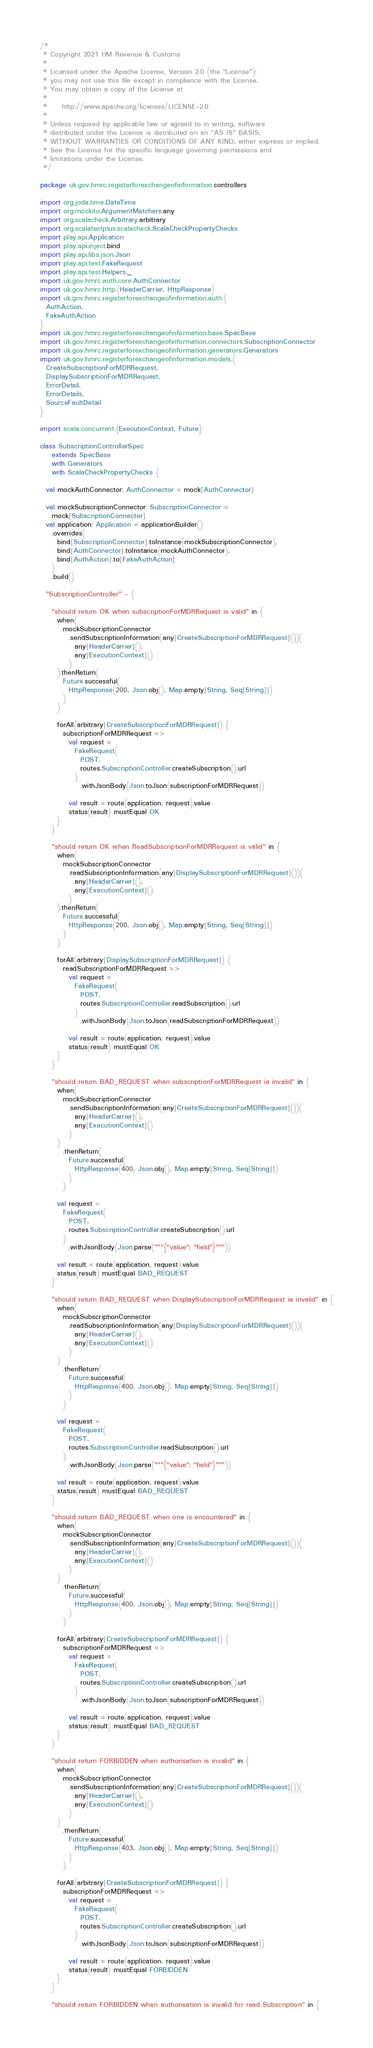Convert code to text. <code><loc_0><loc_0><loc_500><loc_500><_Scala_>/*
 * Copyright 2021 HM Revenue & Customs
 *
 * Licensed under the Apache License, Version 2.0 (the "License");
 * you may not use this file except in compliance with the License.
 * You may obtain a copy of the License at
 *
 *     http://www.apache.org/licenses/LICENSE-2.0
 *
 * Unless required by applicable law or agreed to in writing, software
 * distributed under the License is distributed on an "AS IS" BASIS,
 * WITHOUT WARRANTIES OR CONDITIONS OF ANY KIND, either express or implied.
 * See the License for the specific language governing permissions and
 * limitations under the License.
 */

package uk.gov.hmrc.registerforexchangeofinformation.controllers

import org.joda.time.DateTime
import org.mockito.ArgumentMatchers.any
import org.scalacheck.Arbitrary.arbitrary
import org.scalatestplus.scalacheck.ScalaCheckPropertyChecks
import play.api.Application
import play.api.inject.bind
import play.api.libs.json.Json
import play.api.test.FakeRequest
import play.api.test.Helpers._
import uk.gov.hmrc.auth.core.AuthConnector
import uk.gov.hmrc.http.{HeaderCarrier, HttpResponse}
import uk.gov.hmrc.registerforexchangeofinformation.auth.{
  AuthAction,
  FakeAuthAction
}
import uk.gov.hmrc.registerforexchangeofinformation.base.SpecBase
import uk.gov.hmrc.registerforexchangeofinformation.connectors.SubscriptionConnector
import uk.gov.hmrc.registerforexchangeofinformation.generators.Generators
import uk.gov.hmrc.registerforexchangeofinformation.models.{
  CreateSubscriptionForMDRRequest,
  DisplaySubscriptionForMDRRequest,
  ErrorDetail,
  ErrorDetails,
  SourceFaultDetail
}

import scala.concurrent.{ExecutionContext, Future}

class SubscriptionControllerSpec
    extends SpecBase
    with Generators
    with ScalaCheckPropertyChecks {

  val mockAuthConnector: AuthConnector = mock[AuthConnector]

  val mockSubscriptionConnector: SubscriptionConnector =
    mock[SubscriptionConnector]
  val application: Application = applicationBuilder()
    .overrides(
      bind[SubscriptionConnector].toInstance(mockSubscriptionConnector),
      bind[AuthConnector].toInstance(mockAuthConnector),
      bind[AuthAction].to[FakeAuthAction]
    )
    .build()

  "SubscriptionController" - {

    "should return OK when subscriptionForMDRRequest is valid" in {
      when(
        mockSubscriptionConnector
          .sendSubscriptionInformation(any[CreateSubscriptionForMDRRequest]())(
            any[HeaderCarrier](),
            any[ExecutionContext]()
          )
      ).thenReturn(
        Future.successful(
          HttpResponse(200, Json.obj(), Map.empty[String, Seq[String]])
        )
      )

      forAll(arbitrary[CreateSubscriptionForMDRRequest]) {
        subscriptionForMDRRequest =>
          val request =
            FakeRequest(
              POST,
              routes.SubscriptionController.createSubscription().url
            )
              .withJsonBody(Json.toJson(subscriptionForMDRRequest))

          val result = route(application, request).value
          status(result) mustEqual OK
      }
    }

    "should return OK when ReadSubscriptionForMDRRequest is valid" in {
      when(
        mockSubscriptionConnector
          .readSubscriptionInformation(any[DisplaySubscriptionForMDRRequest]())(
            any[HeaderCarrier](),
            any[ExecutionContext]()
          )
      ).thenReturn(
        Future.successful(
          HttpResponse(200, Json.obj(), Map.empty[String, Seq[String]])
        )
      )

      forAll(arbitrary[DisplaySubscriptionForMDRRequest]) {
        readSubscriptionForMDRRequest =>
          val request =
            FakeRequest(
              POST,
              routes.SubscriptionController.readSubscription().url
            )
              .withJsonBody(Json.toJson(readSubscriptionForMDRRequest))

          val result = route(application, request).value
          status(result) mustEqual OK
      }
    }

    "should return BAD_REQUEST when subscriptionForMDRRequest ia invalid" in {
      when(
        mockSubscriptionConnector
          .sendSubscriptionInformation(any[CreateSubscriptionForMDRRequest]())(
            any[HeaderCarrier](),
            any[ExecutionContext]()
          )
      )
        .thenReturn(
          Future.successful(
            HttpResponse(400, Json.obj(), Map.empty[String, Seq[String]])
          )
        )

      val request =
        FakeRequest(
          POST,
          routes.SubscriptionController.createSubscription().url
        )
          .withJsonBody(Json.parse("""{"value": "field"}"""))

      val result = route(application, request).value
      status(result) mustEqual BAD_REQUEST
    }

    "should return BAD_REQUEST when DisplaySubscriptionForMDRRequest ia invalid" in {
      when(
        mockSubscriptionConnector
          .readSubscriptionInformation(any[DisplaySubscriptionForMDRRequest]())(
            any[HeaderCarrier](),
            any[ExecutionContext]()
          )
      )
        .thenReturn(
          Future.successful(
            HttpResponse(400, Json.obj(), Map.empty[String, Seq[String]])
          )
        )

      val request =
        FakeRequest(
          POST,
          routes.SubscriptionController.readSubscription().url
        )
          .withJsonBody(Json.parse("""{"value": "field"}"""))

      val result = route(application, request).value
      status(result) mustEqual BAD_REQUEST
    }

    "should return BAD_REQUEST when one is encountered" in {
      when(
        mockSubscriptionConnector
          .sendSubscriptionInformation(any[CreateSubscriptionForMDRRequest]())(
            any[HeaderCarrier](),
            any[ExecutionContext]()
          )
      )
        .thenReturn(
          Future.successful(
            HttpResponse(400, Json.obj(), Map.empty[String, Seq[String]])
          )
        )

      forAll(arbitrary[CreateSubscriptionForMDRRequest]) {
        subscriptionForMDRRequest =>
          val request =
            FakeRequest(
              POST,
              routes.SubscriptionController.createSubscription().url
            )
              .withJsonBody(Json.toJson(subscriptionForMDRRequest))

          val result = route(application, request).value
          status(result) mustEqual BAD_REQUEST
      }
    }

    "should return FORBIDDEN when authorisation is invalid" in {
      when(
        mockSubscriptionConnector
          .sendSubscriptionInformation(any[CreateSubscriptionForMDRRequest]())(
            any[HeaderCarrier](),
            any[ExecutionContext]()
          )
      )
        .thenReturn(
          Future.successful(
            HttpResponse(403, Json.obj(), Map.empty[String, Seq[String]])
          )
        )

      forAll(arbitrary[CreateSubscriptionForMDRRequest]) {
        subscriptionForMDRRequest =>
          val request =
            FakeRequest(
              POST,
              routes.SubscriptionController.createSubscription().url
            )
              .withJsonBody(Json.toJson(subscriptionForMDRRequest))

          val result = route(application, request).value
          status(result) mustEqual FORBIDDEN
      }
    }

    "should return FORBIDDEN when authorisation is invalid for read Subscription" in {</code> 